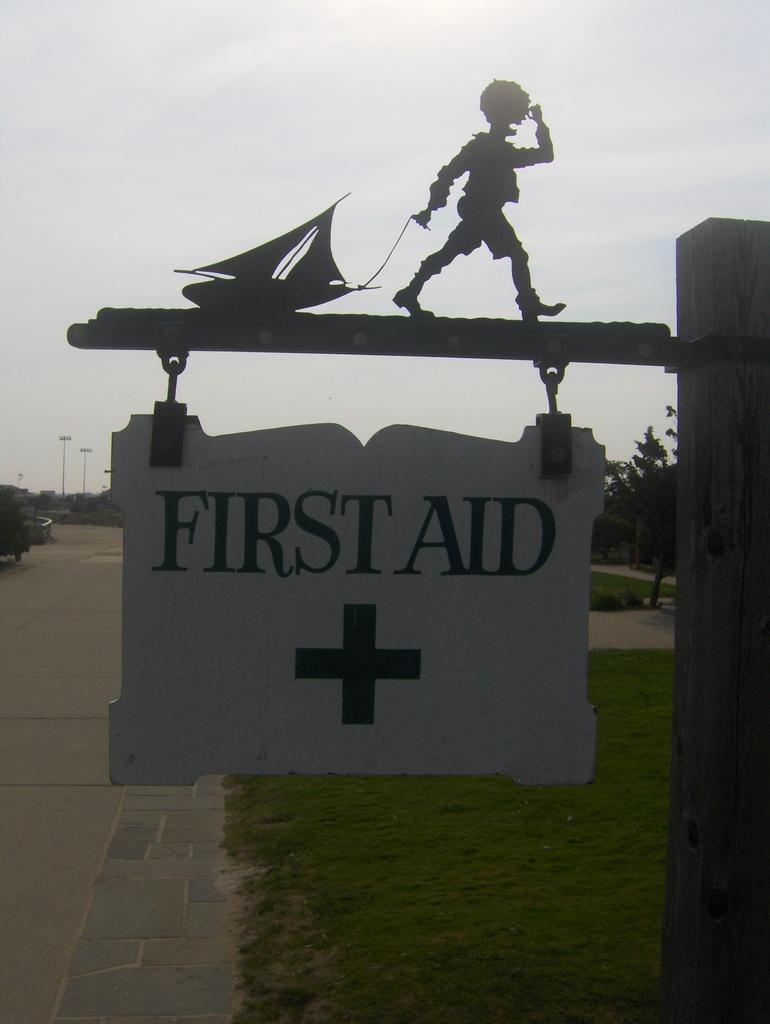Can you describe this image briefly? In the image we can see there is a pole on which a banner is hanging on it it's written "First Aid" and on the top of it there is a small statue of a person standing and holding a rope tied to the boat. There is a ground which is covered with grass. 